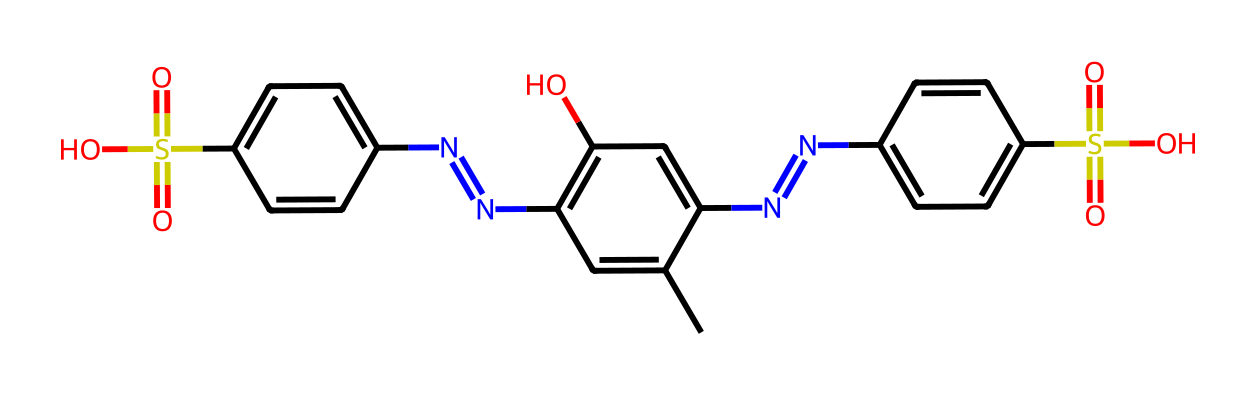What is the total number of nitrogen atoms in this molecule? By inspecting the SMILES representation, we can identify the nitrogen atoms represented by "N". Count each occurrence of "N" in the structure, and there are three instances of nitrogen.
Answer: 3 How many sulfur atoms are present in the molecule? The sulfur atoms are represented by "S" in the SMILES. Looking through the structure, we find two occurrences of "S", indicating the presence of two sulfur atoms.
Answer: 2 What functional group is indicated by "S(=O)(=O)" in the chemical structure? The notation "S(=O)(=O)" indicates that the sulfur atom is bonded to two double-bonded oxygen atoms, forming a sulfonyl group. This functional group is characteristic of sulfonic acids.
Answer: sulfonic acid What type of bonding is primarily present in this molecule? The structure of hair dye molecules, especially with inclusion of nitrogen and sulfur, suggests the presence of aromatic rings, which are known for resonance stability. Most bonds connecting these atoms are covalent, particularly in the context of organic compounds.
Answer: covalent What is the significance of the hydroxyl groups (-OH) in hair dye chemistry? The hydroxyl groups indicated by "O" in the SMILES contribute to the polarity and solubility of hair dye molecules, allowing them to penetrate hair strands effectively, thus enhancing color retention and vividness.
Answer: polarity 